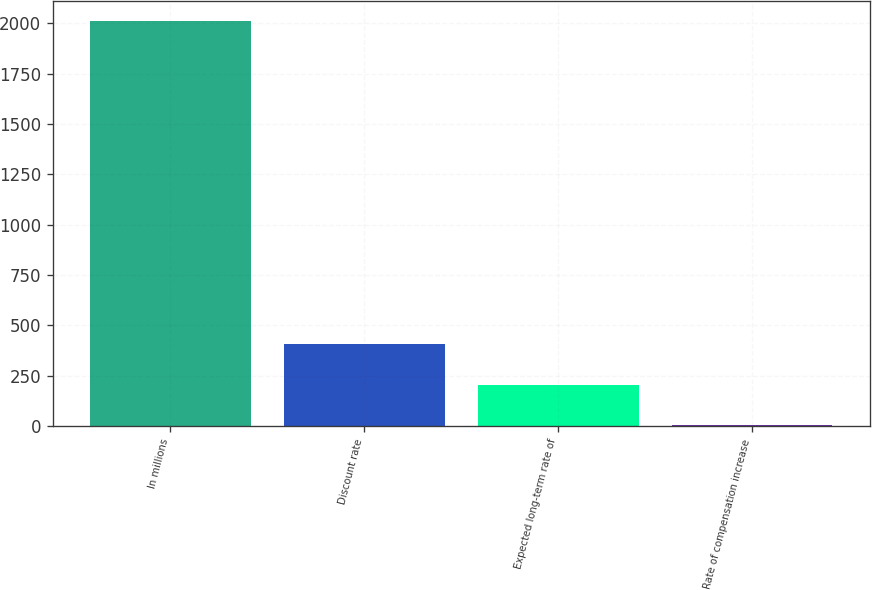Convert chart to OTSL. <chart><loc_0><loc_0><loc_500><loc_500><bar_chart><fcel>In millions<fcel>Discount rate<fcel>Expected long-term rate of<fcel>Rate of compensation increase<nl><fcel>2010<fcel>405.2<fcel>204.6<fcel>4<nl></chart> 